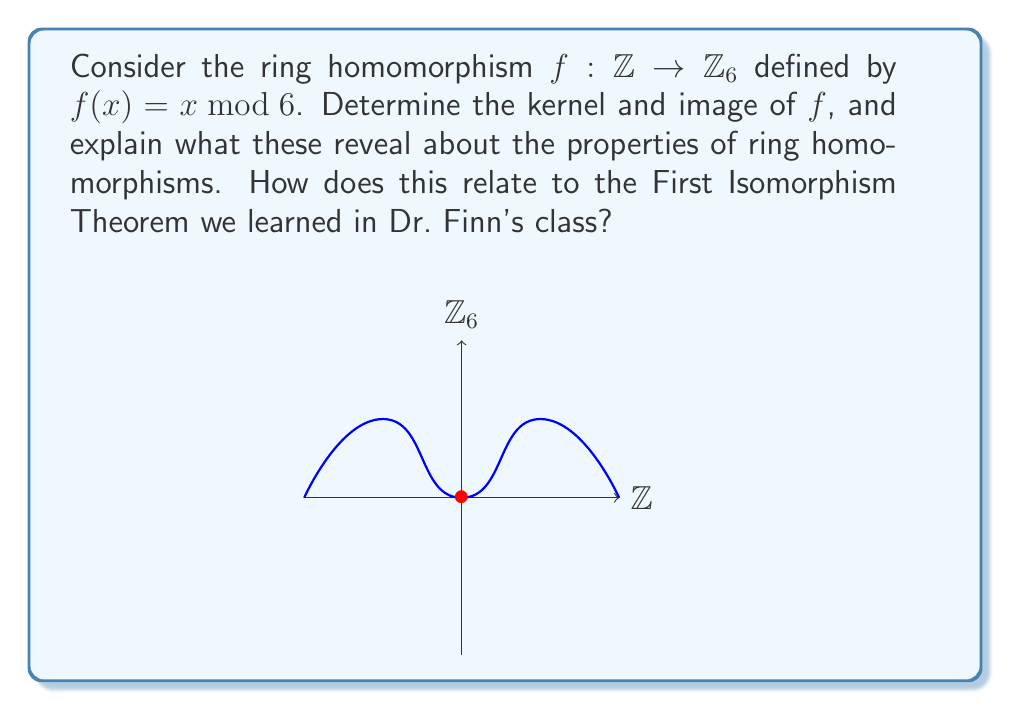What is the answer to this math problem? Let's approach this step-by-step:

1) First, recall that for a ring homomorphism $f: R \to S$, we have:
   a) $f(a+b) = f(a) + f(b)$
   b) $f(ab) = f(a)f(b)$
   c) $f(1_R) = 1_S$ (if the rings have identity)

2) To find the kernel of $f$, we need to determine all $x \in \mathbb{Z}$ such that $f(x) = 0$ in $\mathbb{Z}_6$:
   $$\text{ker}(f) = \{x \in \mathbb{Z} : x \equiv 0 \pmod{6}\} = \{6k : k \in \mathbb{Z}\} = 6\mathbb{Z}$$

3) The image of $f$ is all possible outputs in $\mathbb{Z}_6$:
   $$\text{im}(f) = \{0, 1, 2, 3, 4, 5\} = \mathbb{Z}_6$$

4) Properties revealed:
   a) The kernel is an ideal of $\mathbb{Z}$, specifically $6\mathbb{Z}$.
   b) The image is a subring of $\mathbb{Z}_6$, in this case, all of $\mathbb{Z}_6$.

5) Relating to the First Isomorphism Theorem:
   The theorem states that for a ring homomorphism $f: R \to S$, we have:
   $$R/\text{ker}(f) \cong \text{im}(f)$$

   In this case, $\mathbb{Z}/6\mathbb{Z} \cong \mathbb{Z}_6$, which is indeed true.

This example demonstrates key properties of ring homomorphisms: preservation of algebraic structure, the relationship between the kernel and the domain, and the connection between the image and the codomain.
Answer: $\text{ker}(f) = 6\mathbb{Z}$, $\text{im}(f) = \mathbb{Z}_6$; illustrates ideal/subring properties and First Isomorphism Theorem. 